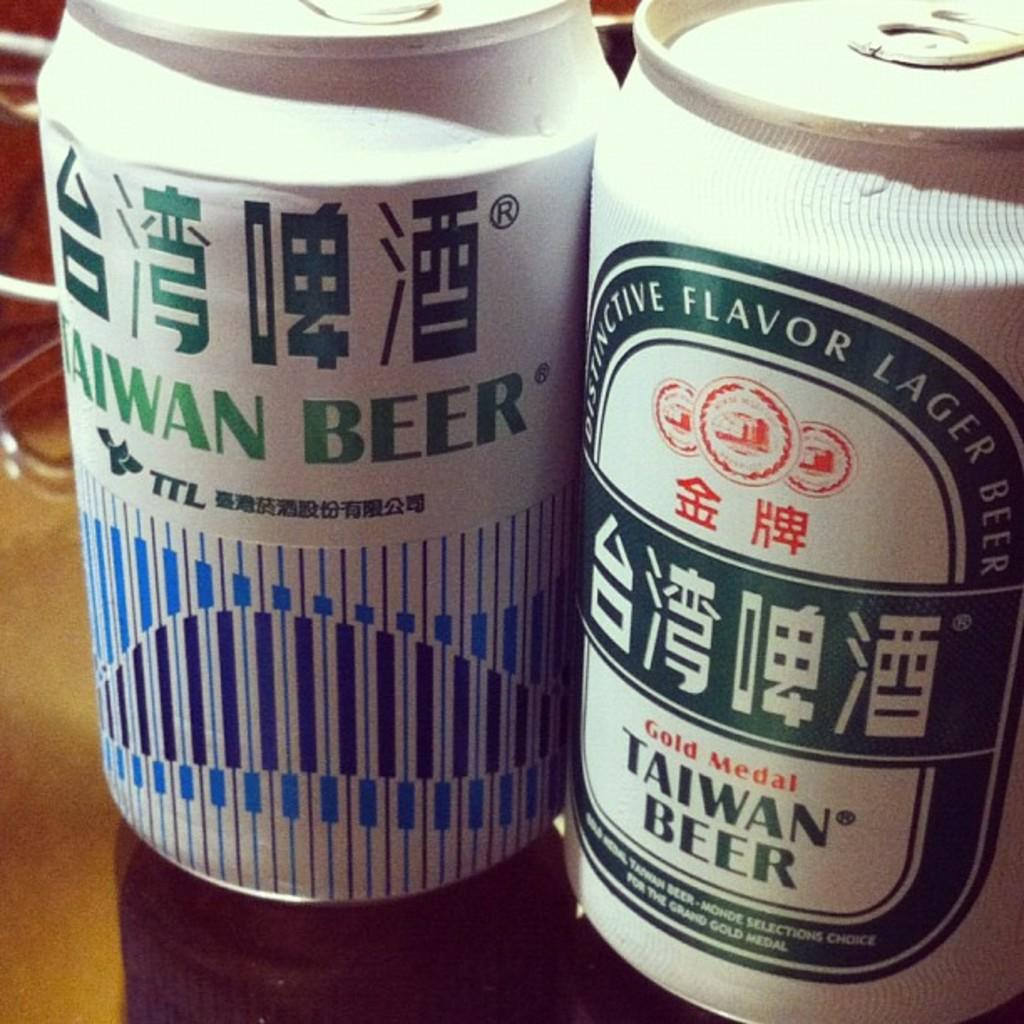<image>
Give a short and clear explanation of the subsequent image. Two cans of Taiwan Beer standing next to each other. 